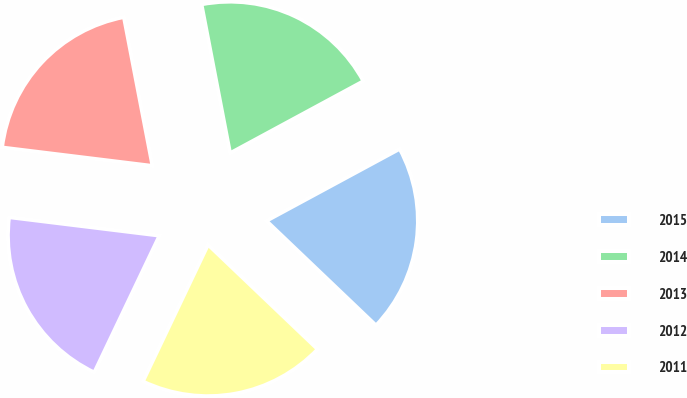Convert chart. <chart><loc_0><loc_0><loc_500><loc_500><pie_chart><fcel>2015<fcel>2014<fcel>2013<fcel>2012<fcel>2011<nl><fcel>20.01%<fcel>20.14%<fcel>20.04%<fcel>19.87%<fcel>19.95%<nl></chart> 